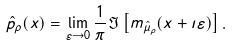<formula> <loc_0><loc_0><loc_500><loc_500>\hat { p } _ { \rho } ( x ) & = \lim _ { \varepsilon \to 0 } \frac { 1 } { \pi } \Im \left [ m _ { \hat { \mu } _ { \rho } } ( x + \imath \varepsilon ) \right ] .</formula> 